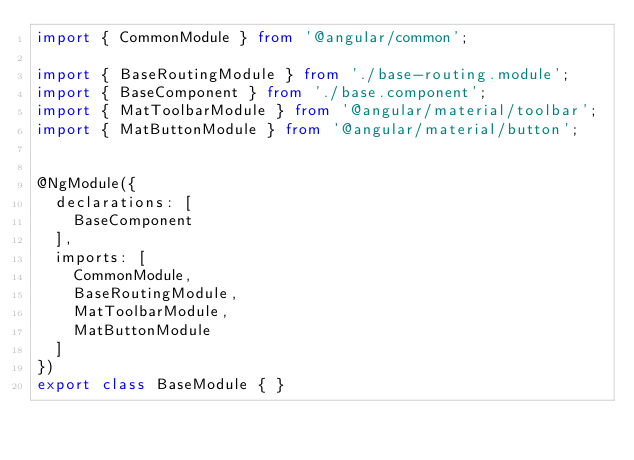Convert code to text. <code><loc_0><loc_0><loc_500><loc_500><_TypeScript_>import { CommonModule } from '@angular/common';

import { BaseRoutingModule } from './base-routing.module';
import { BaseComponent } from './base.component';
import { MatToolbarModule } from '@angular/material/toolbar';
import { MatButtonModule } from '@angular/material/button';


@NgModule({
  declarations: [
    BaseComponent
  ],
  imports: [
    CommonModule,
    BaseRoutingModule,
    MatToolbarModule,
    MatButtonModule
  ]
})
export class BaseModule { }
</code> 